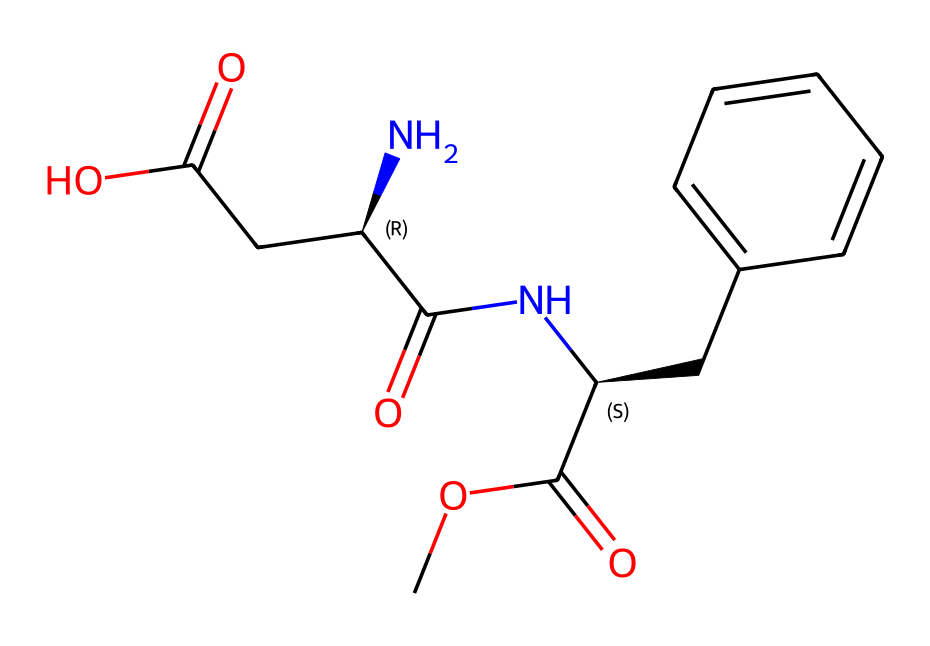What is the total number of carbon atoms in aspartame? To determine the total number of carbon atoms, we can identify each carbon in the SMILES representation. The molecule contains multiple carbon atoms structured in various functional groups. Counting them gives us a total of 13 carbon atoms.
Answer: 13 How many chiral centers are present in aspartame? By examining the SMILES and identifying the stereogenic centers (labeled with '@'), we find that there are two chiral centers in the structure of aspartame.
Answer: 2 Which functional group is prominent in the structure of aspartame? Aspartame features multiple functional groups, but the most prominent ones include the amide group and ester group, characteristic of its structure. The presence of a carbonyl adjacent to a nitrogen signals an amide.
Answer: amide Which part of the chemical makes aspartame sweet? The sweetness of aspartame is primarily due to its specific molecular arrangement, particularly the aromatic ring structure that enhances sweetness perception in taste receptors.
Answer: aromatic ring What is the molecular formula of aspartame? To derive the molecular formula from the SMILES, we count all atoms of each element present in the structure, leading to the molecular formula C13H16N2O3.
Answer: C13H16N2O3 Is aspartame a natural or synthetic compound? Aspartame is synthesized through a chemical process and is not found in nature, making it a synthetic compound.
Answer: synthetic What type of compound is aspartame categorized as? Aspartame is categorized as a chiral compound due to the presence of chiral centers in its structure which allows for an enantiomeric form.
Answer: chiral compound 